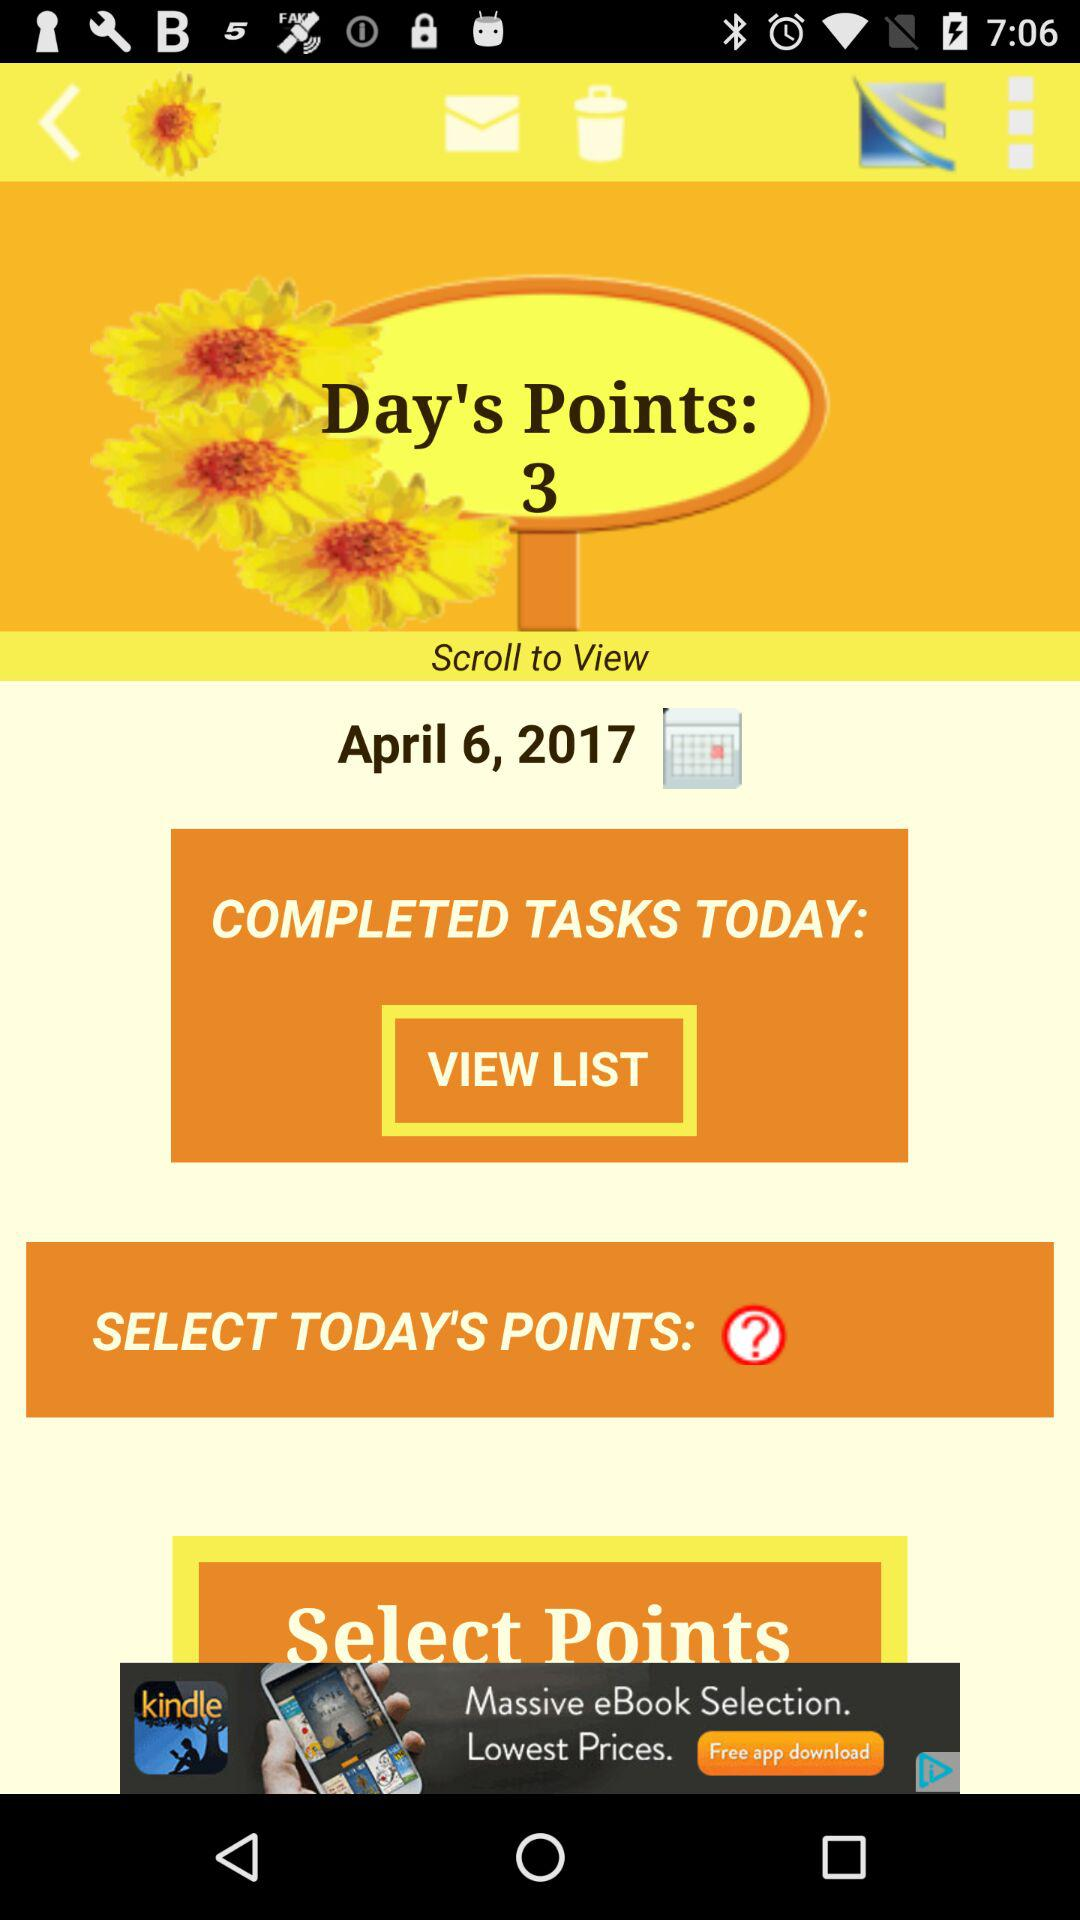How many points are available to select?
Answer the question using a single word or phrase. 3 